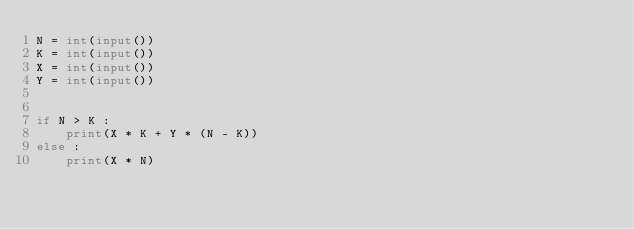<code> <loc_0><loc_0><loc_500><loc_500><_Python_>N = int(input())
K = int(input())
X = int(input())
Y = int(input())


if N > K :
    print(X * K + Y * (N - K))
else : 
    print(X * N)</code> 